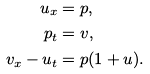Convert formula to latex. <formula><loc_0><loc_0><loc_500><loc_500>u _ { x } & = p , \\ p _ { t } & = v , \\ v _ { x } - u _ { t } & = p ( 1 + u ) .</formula> 